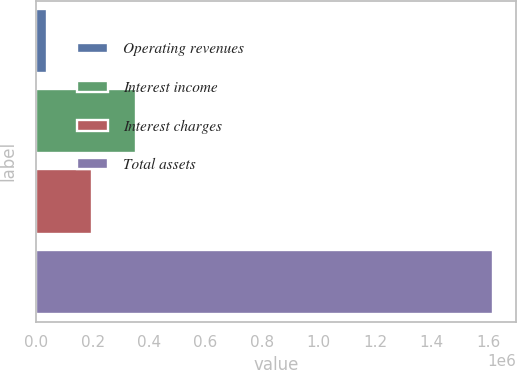Convert chart to OTSL. <chart><loc_0><loc_0><loc_500><loc_500><bar_chart><fcel>Operating revenues<fcel>Interest income<fcel>Interest charges<fcel>Total assets<nl><fcel>38036<fcel>354334<fcel>196185<fcel>1.61953e+06<nl></chart> 